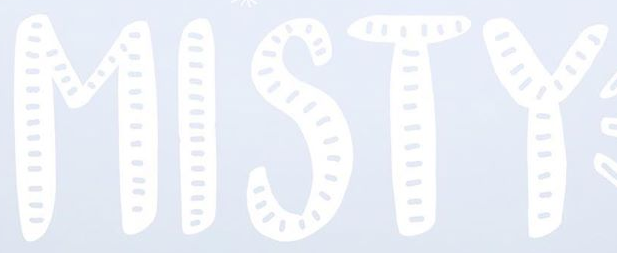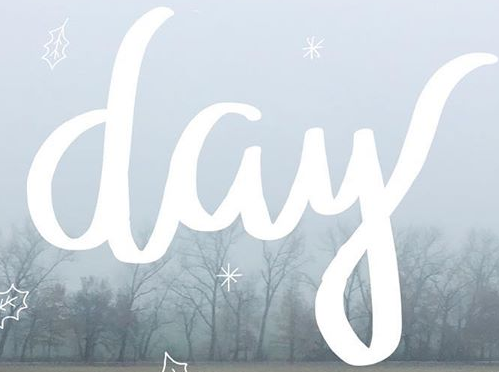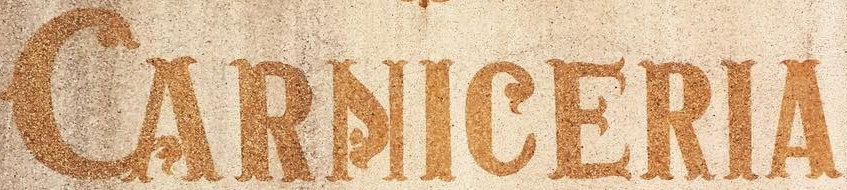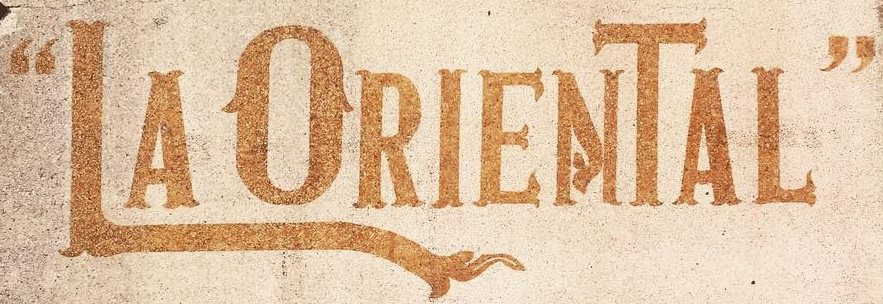Read the text from these images in sequence, separated by a semicolon. MISTY; day; CARNICERIA; “LAORIENTAL" 